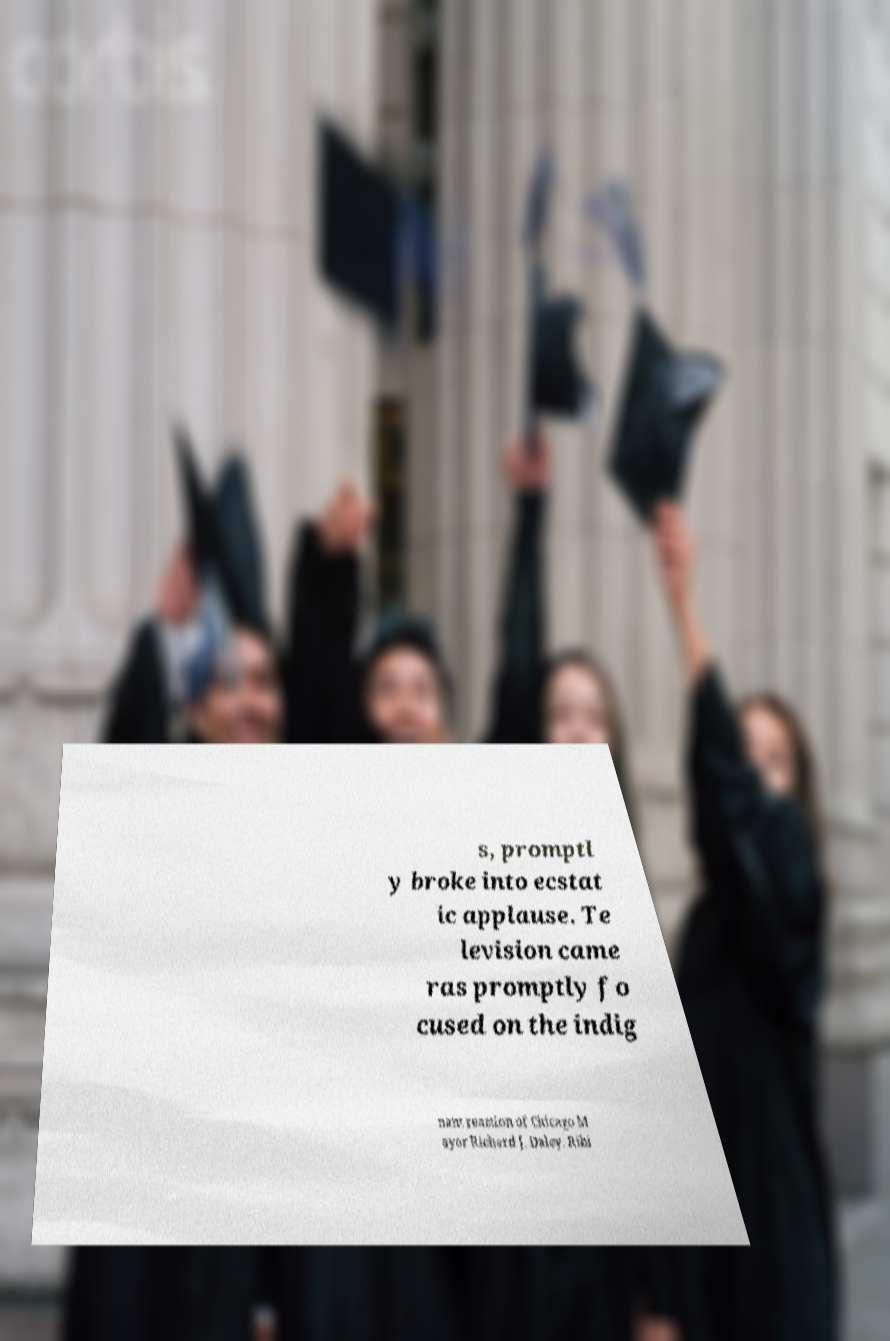I need the written content from this picture converted into text. Can you do that? s, promptl y broke into ecstat ic applause. Te levision came ras promptly fo cused on the indig nant reaction of Chicago M ayor Richard J. Daley. Ribi 